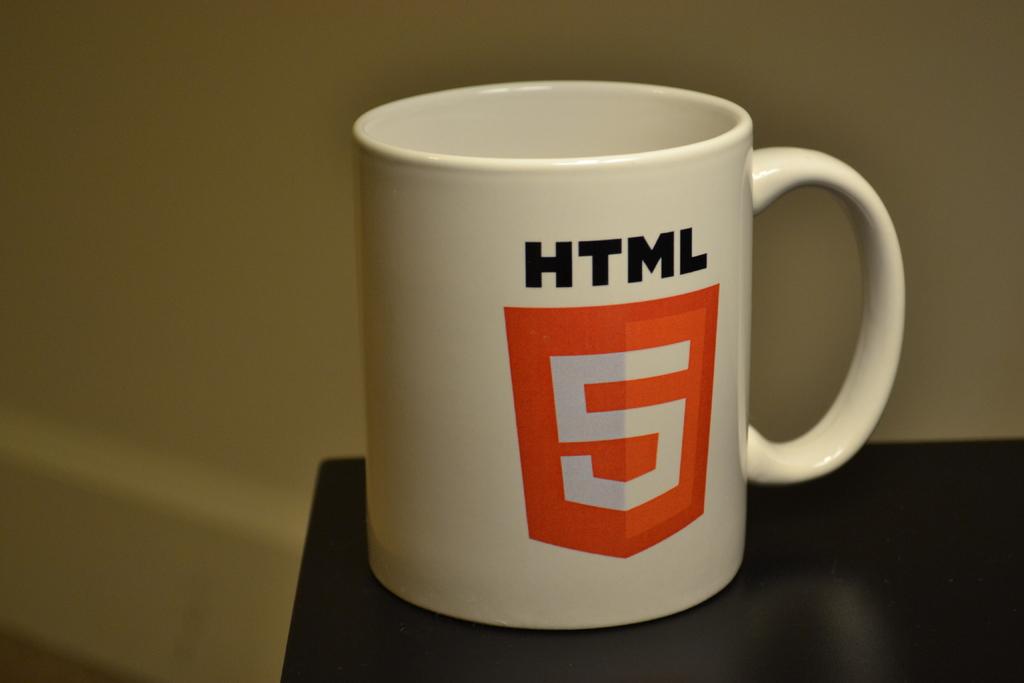Is the html mug from a programming company?
Give a very brief answer. Unanswerable. What number is on the mug?
Offer a very short reply. 5. 